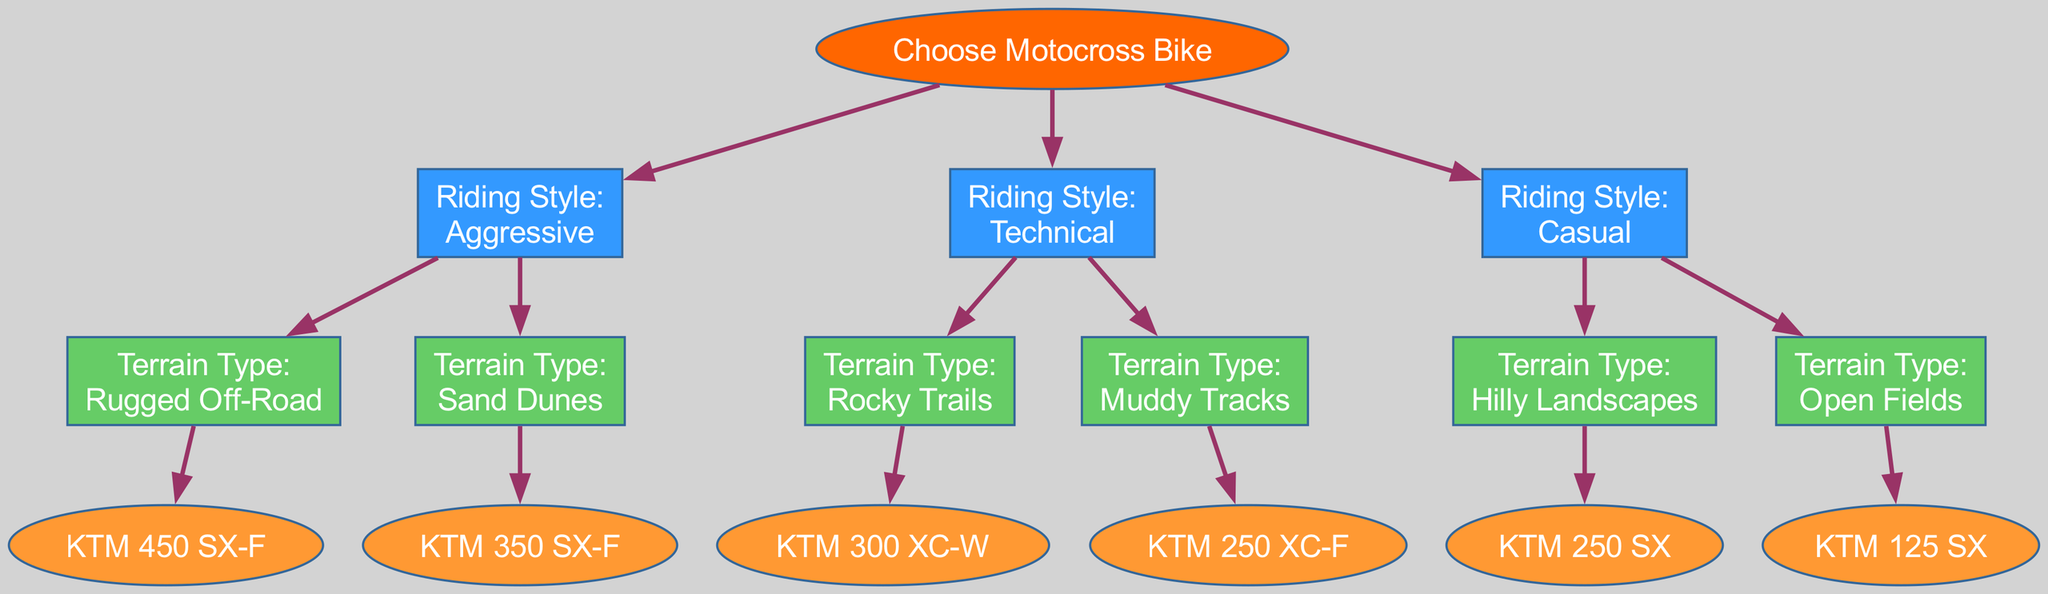What bike is recommended for aggressive riding on rugged off-road terrain? The diagram indicates that for aggressive riding style on rugged off-road terrain, the recommended bike is "KTM 450 SX-F". This is obtained by tracing the "Aggressive" node to the "Rugged Off-Road" node, which leads to the bike model leaf.
Answer: KTM 450 SX-F Which bike is associated with technical riding on muddy tracks? According to the diagram, the bike linked to technical riding style on muddy tracks is "KTM 250 XC-F". This is determined by following the "Technical" node to the "Muddy Tracks" node and then to the corresponding bike model.
Answer: KTM 250 XC-F How many different bike models are presented in the diagram? The total number of bike models in the diagram is six. This is calculated by counting each leaf node that contains a bike model under the respective terrain types for all riding styles.
Answer: 6 What is the terrain type for casual riding style? For the casual riding style, there are two terrain types listed in the diagram: "Hilly Landscapes" and "Open Fields." The diagram shows branches for both terrains leading out of the "Casual" riding style node.
Answer: Hilly Landscapes, Open Fields If someone prefers riding on rocky trails, which bike should they choose? The diagram specifies that for those who prefer riding on rocky trails, the recommended bike is "KTM 300 XC-W". This can be found by following the path from "Technical" to "Rocky Trails," which connects to its designated bike node.
Answer: KTM 300 XC-W What color represents the riding style nodes in the diagram? The color used for the riding style nodes is "#3399FF". This can be observed in the diagram styling attributes where the node color is defined for the riding styles.
Answer: #3399FF Which terrain type leads to the KTM 125 SX bike? The terrain type leading to the "KTM 125 SX" bike is "Open Fields". This can be traced by following the "Casual" riding style node down to the "Open Fields" node where the bike is linked.
Answer: Open Fields Which bike should be chosen for riding in sand dunes if the rider is aggressive? The bike selected for aggressive riding in sand dunes is "KTM 350 SX-F". This is obtained by following the "Aggressive" riding style node to the "Sand Dunes" terrain node that connects to the bike model.
Answer: KTM 350 SX-F What is the primary decision-making factor in this diagram? The primary decision-making factor depicted in the diagram is the riding style. It serves as the first node from which the diagram branches out into different terrain types and ultimately leads to specific bike recommendations.
Answer: Riding Style 